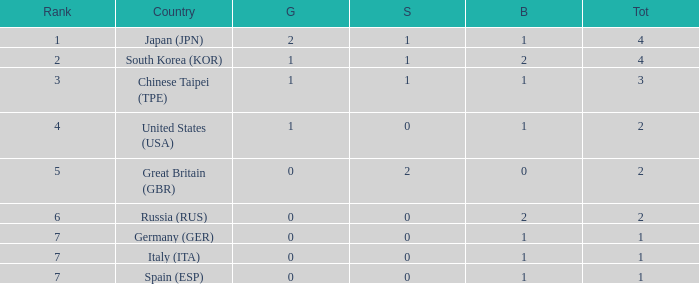How many total medals does a country with more than 1 silver medals have? 2.0. 